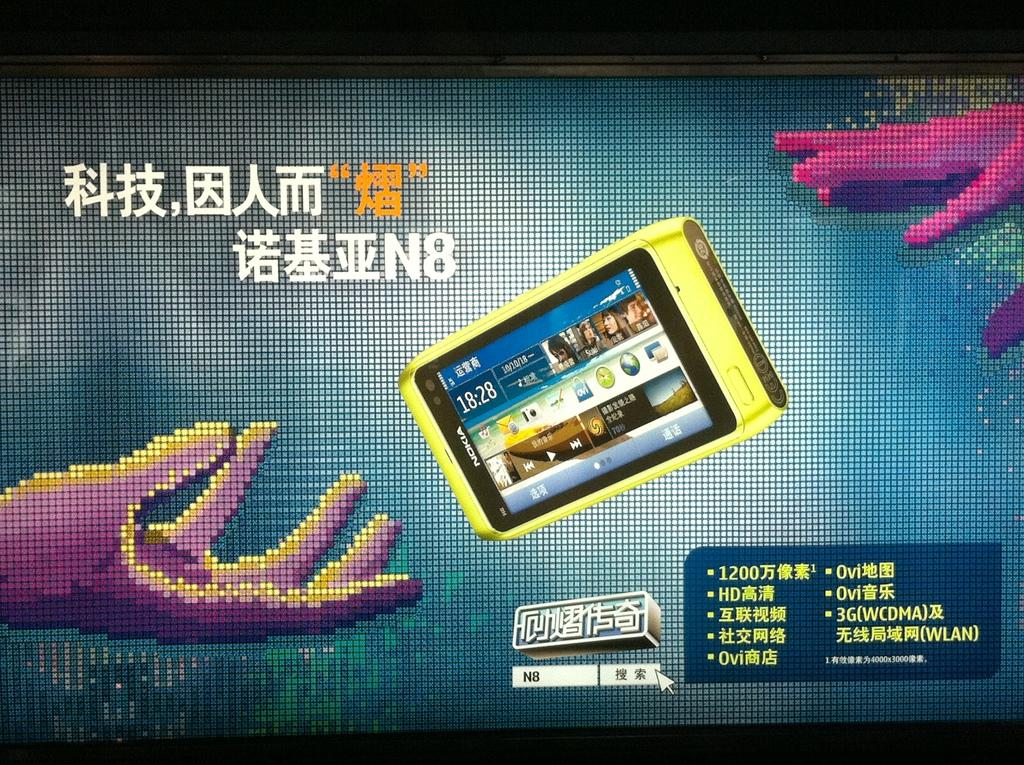<image>
Provide a brief description of the given image. An ad for a cell phone has a time of 18:28 on the phone screen. 